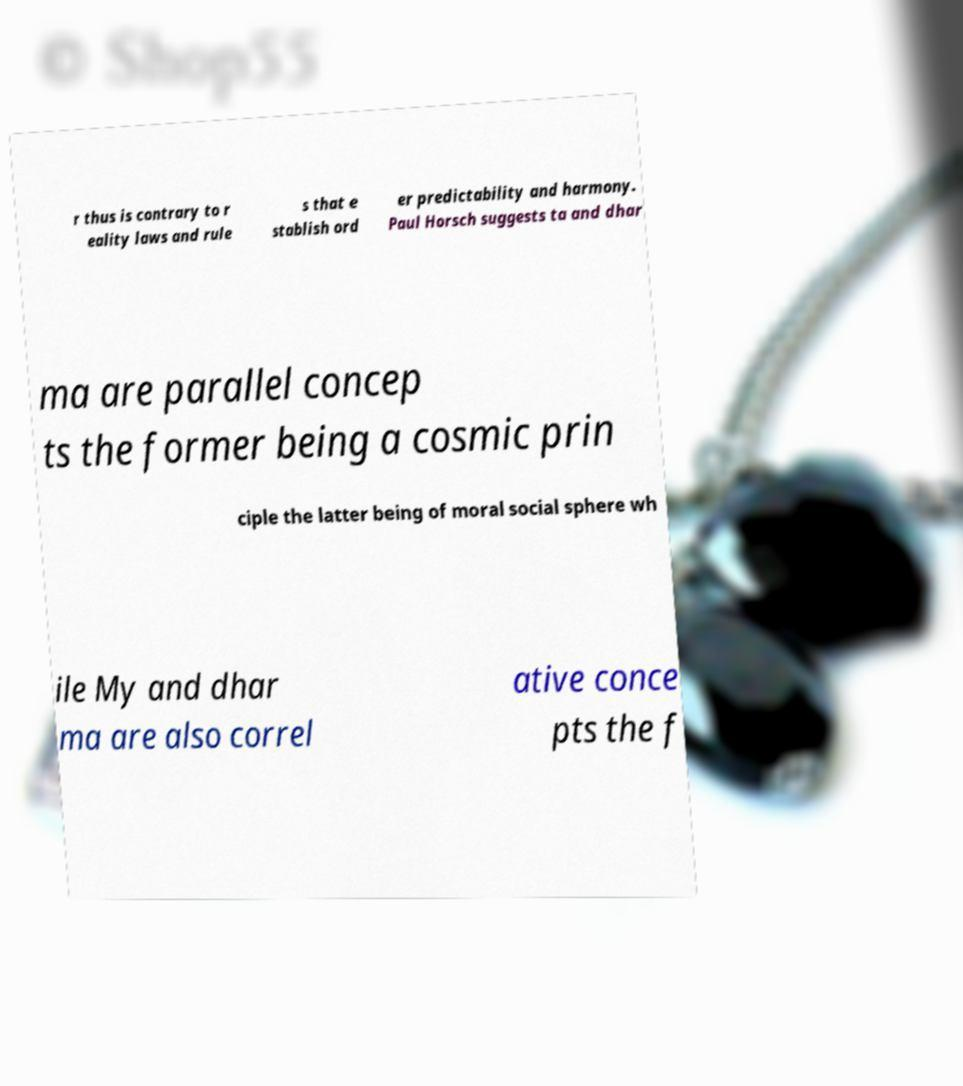I need the written content from this picture converted into text. Can you do that? r thus is contrary to r eality laws and rule s that e stablish ord er predictability and harmony. Paul Horsch suggests ta and dhar ma are parallel concep ts the former being a cosmic prin ciple the latter being of moral social sphere wh ile My and dhar ma are also correl ative conce pts the f 